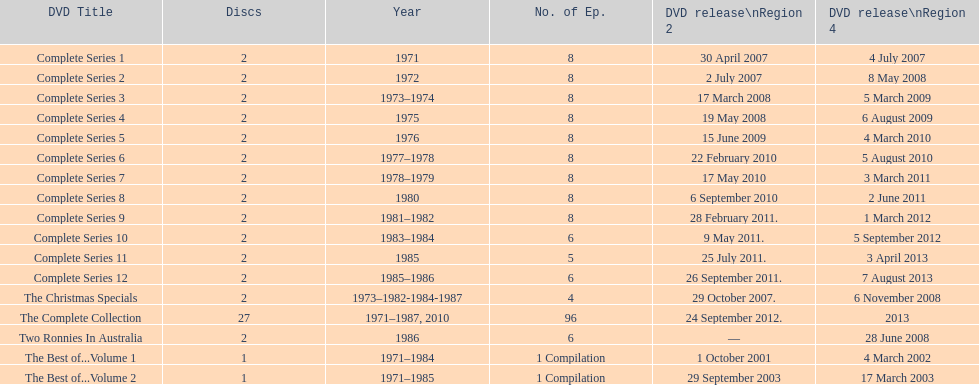What is the combined amount of all the discs displayed in the table? 57. 